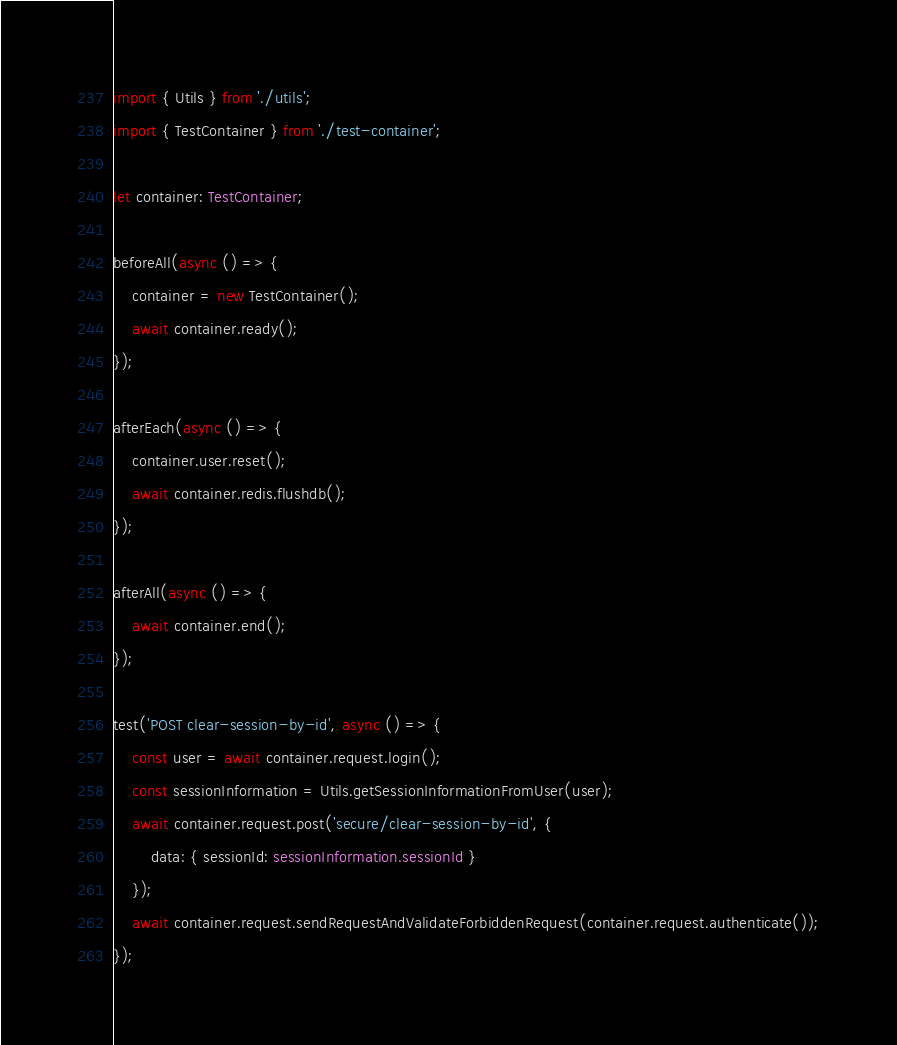Convert code to text. <code><loc_0><loc_0><loc_500><loc_500><_TypeScript_>import { Utils } from './utils';
import { TestContainer } from './test-container';

let container: TestContainer;

beforeAll(async () => {
    container = new TestContainer();
    await container.ready();
});

afterEach(async () => {
    container.user.reset();
    await container.redis.flushdb();
});

afterAll(async () => {
    await container.end();
});

test('POST clear-session-by-id', async () => {
    const user = await container.request.login();
    const sessionInformation = Utils.getSessionInformationFromUser(user);
    await container.request.post('secure/clear-session-by-id', {
        data: { sessionId: sessionInformation.sessionId }
    });
    await container.request.sendRequestAndValidateForbiddenRequest(container.request.authenticate());
});
</code> 